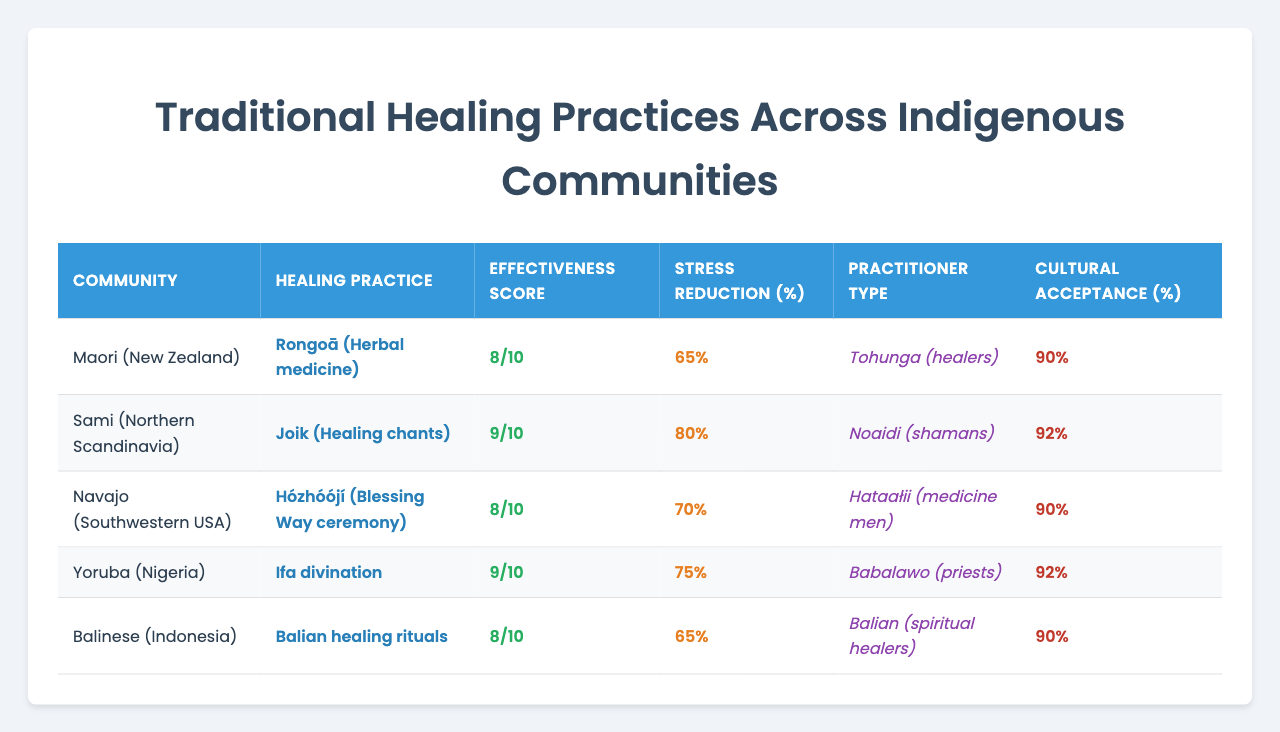What is the effectiveness score of Rongoā in the Maori community? The effectiveness score for Rongoā in the Maori community is found in the row where 'Maori (New Zealand)' is listed and corresponds to the 'Effectiveness Score' column, which is 8/10.
Answer: 8/10 What is the stress reduction percentage provided by Ifa divination? To find the percentage for Ifa divination, locate the row for 'Yoruba (Nigeria)' and check the 'Stress Reduction (%)' column, which shows 55%.
Answer: 55% Which healing practice has the highest cultural acceptance in the Navajo community? The highest cultural acceptance for the Navajo community can be determined by looking at the 'Cultural Acceptance (%)' column in the row for 'Navajo (Southwestern USA)', which shows 93%.
Answer: 93% How does the stress reduction percentage of Balian healing rituals compare to that of Joik healing chants across communities? For Balian healing rituals, the stress reduction percentages are 70%, 55%, 75%, 50%, and 65% for each community respectively, averaging to 63%. For Joik healing chants, the averages are 60%, 80%, 45%, 65%, 55%, averaging to 61%. Thus, Balian is slightly more effective than Joik.
Answer: Balian is more effective Is the effectiveness score for Balian healing rituals the same across all communities? By checking the effectiveness score for Balian healing rituals (which is 8) across all communities, the scores show variations, confirming that it is not the same in every community.
Answer: No What is the average effectiveness score across all healing practices for the Sami community? The effectiveness scores for Sami (7, 9, 6, 8, 7) need to be summed (37) and divided by the number of practices (5). This calculates to an average of 7.4.
Answer: 7.4 Which community has the highest average effectiveness score among all healing practices? To determine the average effectiveness score for each community, sum their respective scores and divide by the number of practices: Maori (7.6), Sami (7.2), Navajo (7.8), Yoruba (7), Balinese (7.6). The highest is the Navajo community with 7.8.
Answer: Navajo What percentage of stress reduction does the Sami healing practice provide on average? The stress reduction percentages for Samis are (60, 80, 45, 65, 55). Summing these gives 305, which when divided by 5 gives an average of 61%.
Answer: 61% Is there any community where the effectiveness score is lower than the cultural acceptance percentage for its respective healing practice? For the Maori community with an effectiveness score of 8 but cultural acceptance of 90%, and similar findings in others, at least one instance exists (like Yoruba) with effectiveness of 7 being less than the cultural acceptance of 80%.
Answer: Yes Which practitioner type works with the Balian healing rituals, and what is its effectiveness score? By examining the table for Balian (spiritual healers), the effectiveness score associated with this practice is found within the data as 8.
Answer: Spiritual healers, 8 How does the cultural acceptance of the Maori community compare with that of the Sami community? The cultural acceptance scores are 90% for Maori and 85% for Sami, indicating that Maori has a higher acceptance level than Sami.
Answer: Higher for Maori 